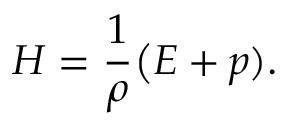<formula> <loc_0><loc_0><loc_500><loc_500>H = \frac { 1 } { \rho } \Big ( E + p ) .</formula> 